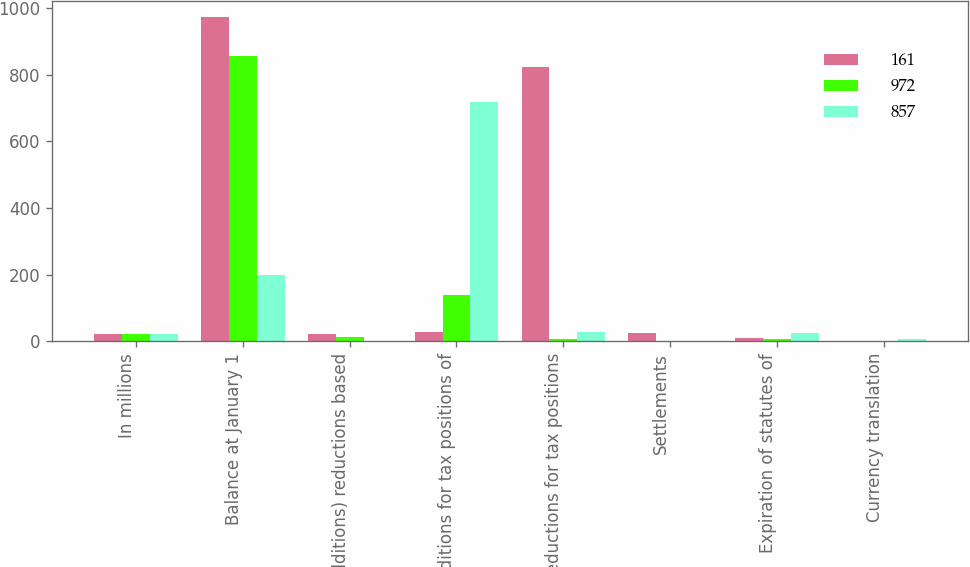<chart> <loc_0><loc_0><loc_500><loc_500><stacked_bar_chart><ecel><fcel>In millions<fcel>Balance at January 1<fcel>(Additions) reductions based<fcel>Additions for tax positions of<fcel>Reductions for tax positions<fcel>Settlements<fcel>Expiration of statutes of<fcel>Currency translation<nl><fcel>161<fcel>22<fcel>972<fcel>22<fcel>29<fcel>824<fcel>26<fcel>11<fcel>1<nl><fcel>972<fcel>22<fcel>857<fcel>12<fcel>140<fcel>6<fcel>2<fcel>7<fcel>2<nl><fcel>857<fcel>22<fcel>199<fcel>2<fcel>719<fcel>29<fcel>2<fcel>25<fcel>7<nl></chart> 